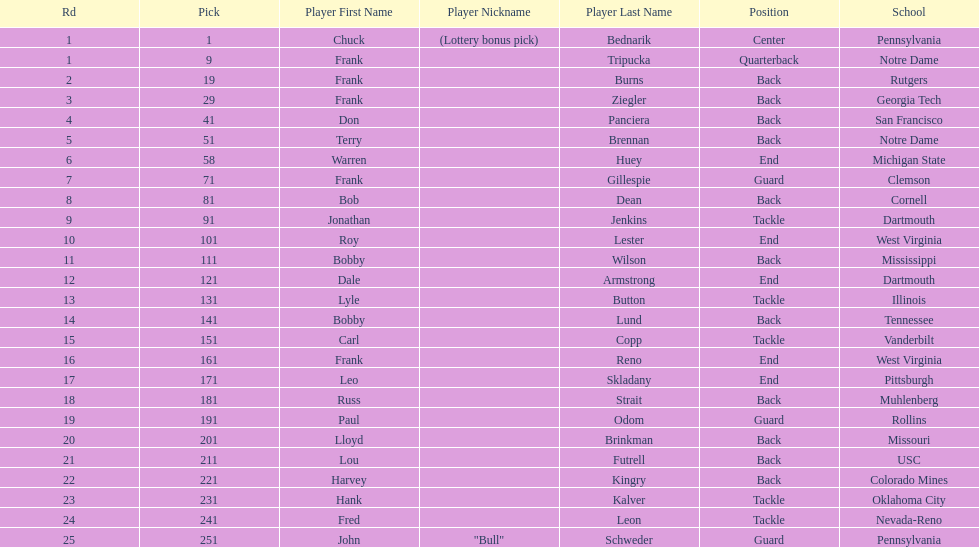Who was the player that the team drafted after bob dean? Jonathan Jenkins. 